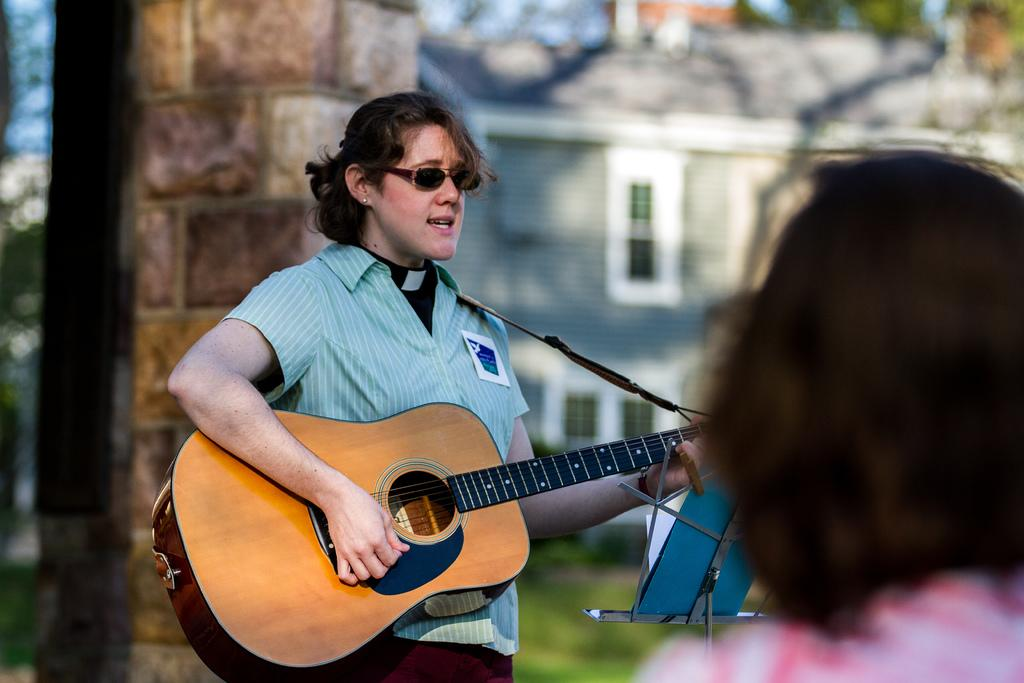What is the lady in the image holding? The lady is holding a guitar in the image. What is the lady doing with the guitar? The lady is singing while holding the guitar. Is there anyone else in the image besides the lady with the guitar? Yes, there is a woman watching the lady in the image. What type of potato is the lady using as a prop while singing in the image? There is no potato present in the image; the lady is holding a guitar and singing. 